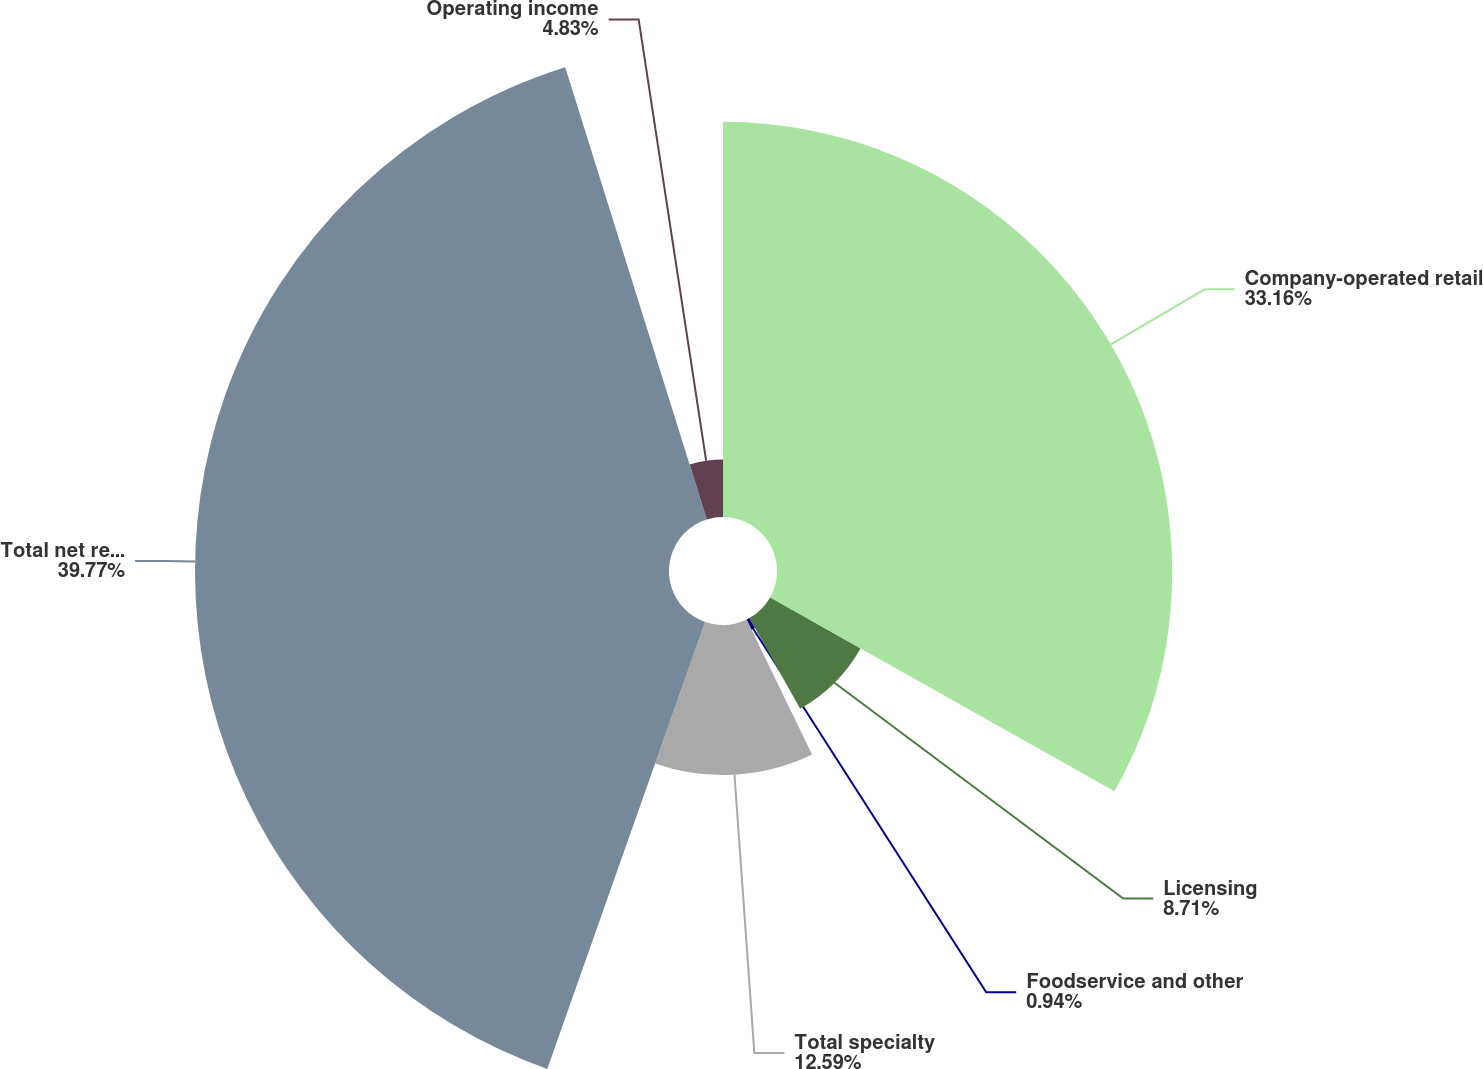Convert chart. <chart><loc_0><loc_0><loc_500><loc_500><pie_chart><fcel>Company-operated retail<fcel>Licensing<fcel>Foodservice and other<fcel>Total specialty<fcel>Total net revenues<fcel>Operating income<nl><fcel>33.16%<fcel>8.71%<fcel>0.94%<fcel>12.59%<fcel>39.77%<fcel>4.83%<nl></chart> 